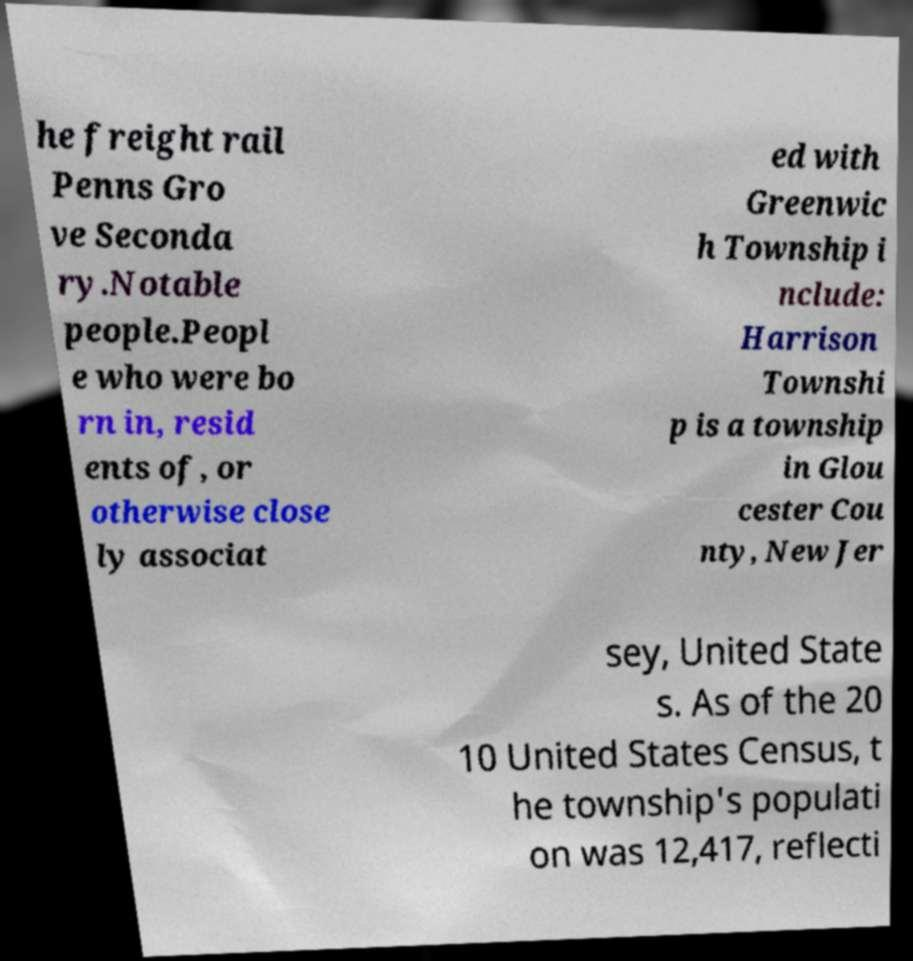There's text embedded in this image that I need extracted. Can you transcribe it verbatim? he freight rail Penns Gro ve Seconda ry.Notable people.Peopl e who were bo rn in, resid ents of, or otherwise close ly associat ed with Greenwic h Township i nclude: Harrison Townshi p is a township in Glou cester Cou nty, New Jer sey, United State s. As of the 20 10 United States Census, t he township's populati on was 12,417, reflecti 